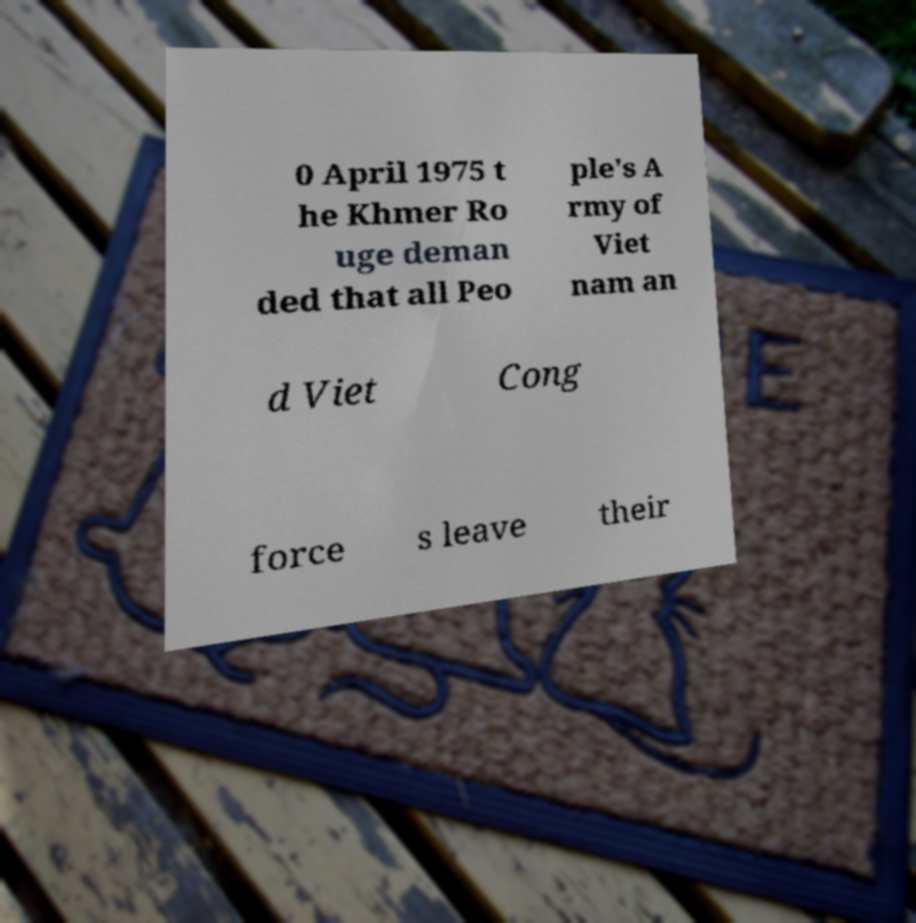There's text embedded in this image that I need extracted. Can you transcribe it verbatim? 0 April 1975 t he Khmer Ro uge deman ded that all Peo ple's A rmy of Viet nam an d Viet Cong force s leave their 